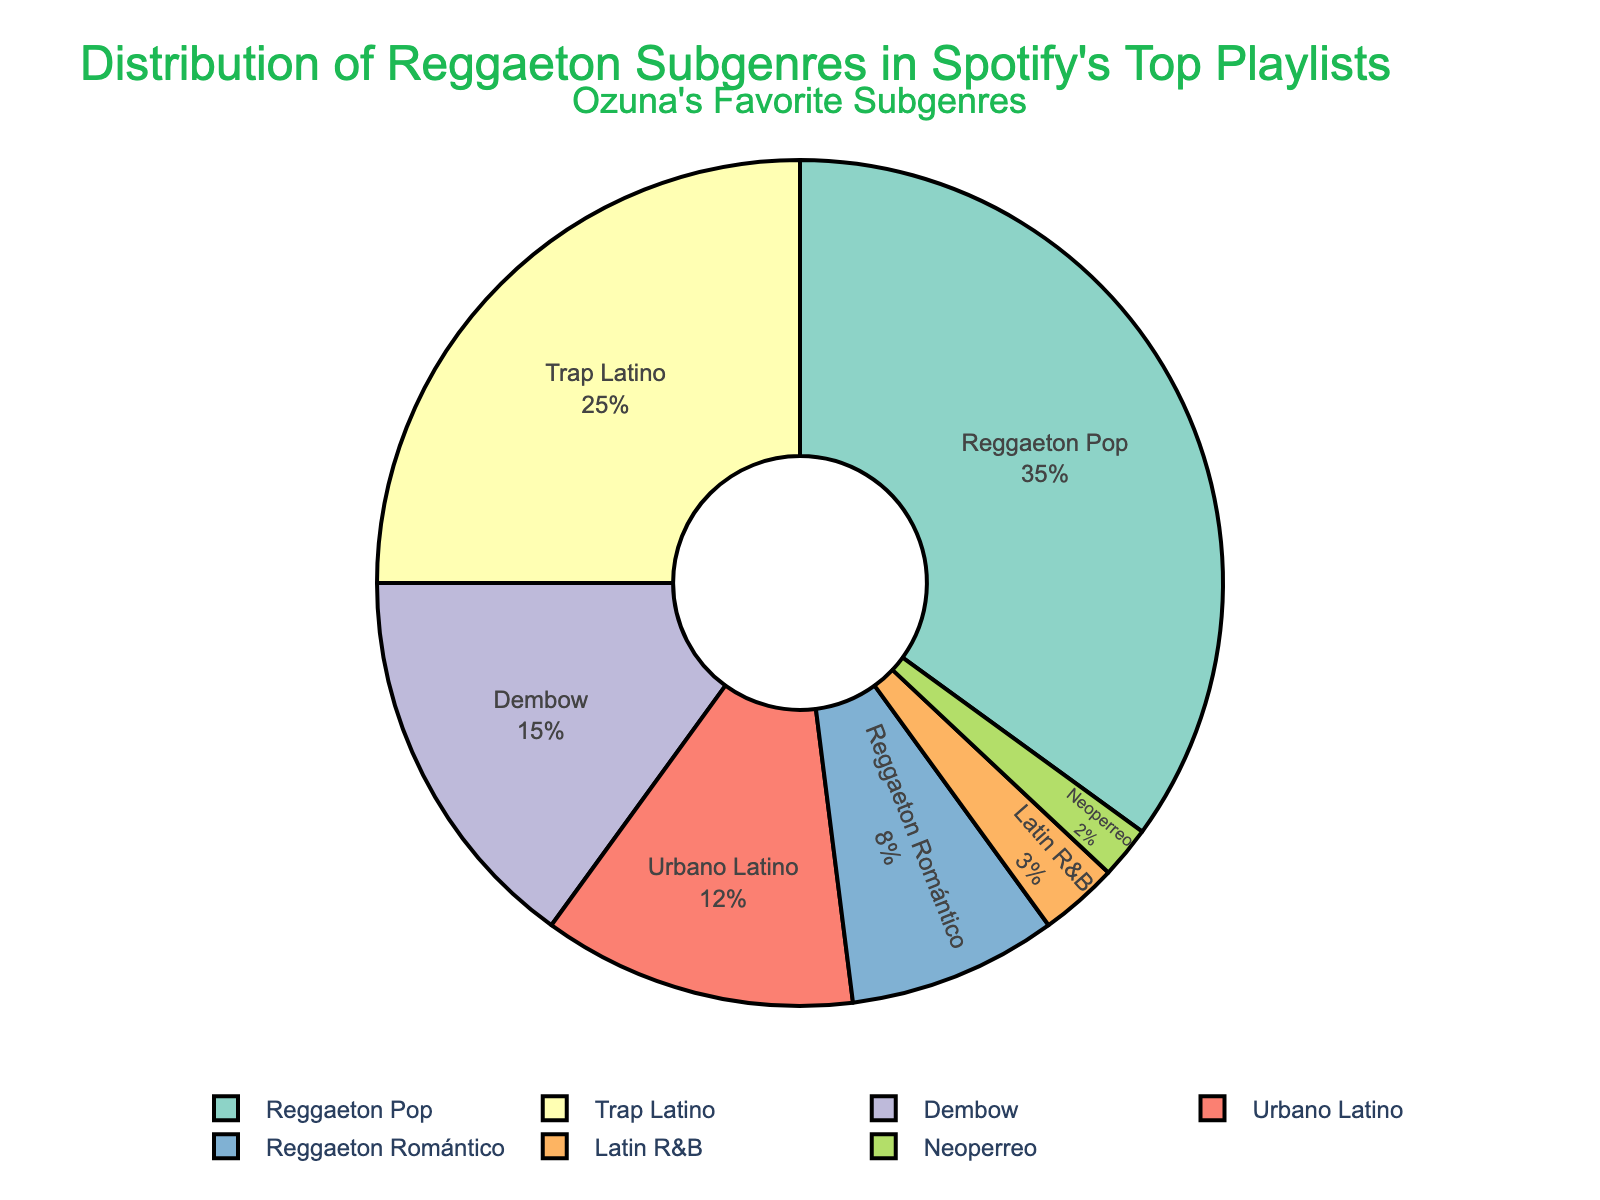What's the most popular reggaeton subgenre in Spotify's top playlists? The pie chart shows that "Reggaeton Pop" has the largest slice, representing 35% of the total distribution, which is the highest percentage among all subgenres.
Answer: Reggaeton Pop How much more popular is Trap Latino compared to Reggaeton Romántico? Trap Latino has 25% and Reggaeton Romántico has 8%. By subtracting 8% from 25%, we get the difference.
Answer: 17% What is the combined percentage of Dembow and Urbano Latino? Dembow has 15% and Urbano Latino has 12%. Adding these two percentages together results in 27%.
Answer: 27% Which subgenre has the smallest percentage? Neoperreo has the smallest slice in the pie chart, representing 2% of the total distribution.
Answer: Neoperreo How much smaller is Latin R&B's share compared to Urbano Latino's? Urbano Latino is 12% and Latin R&B is 3%. By subtracting 3% from 12%, you get the difference.
Answer: 9% Which two subgenres together make up exactly half of Spotify's top playlists? The top two subgenres are Reggaeton Pop and Trap Latino, which are 35% and 25%, respectively. Adding these two percentages together gives 60%, not 50%. Checking the next possible pairs: Dembow and Urbano Latino, which are 15% and 12%, totaling 27%; none of these pairings add up to exactly 50%.
Answer: None (there's no such pair) What is the average percentage of all reggaeton subgenres listed in the pie chart? The percentages are 35, 25, 15, 12, 8, 3, and 2. Summing them equals 100 which is the total distribution. Dividing 100 by 7 (total subgenres) gives approximately 14.3%.
Answer: 14.3% If you were to combine Reggaeton Romántico and Neoperreo, what percentage would they constitute together? Reggaeton Romántico is 8% and Neoperreo is 2%. Adding these two percentages together results in 10%.
Answer: 10% How many subgenres have a share of 10% or more in Spotify's top playlists? We see that Reggaeton Pop (35%), Trap Latino (25%), Dembow (15%), and Urbano Latino (12%) each have more than 10%.
Answer: 4 What is the percentage difference between the largest and smallest subgenres? The largest subgenre (Reggaeton Pop) has 35% and the smallest (Neoperreo) has 2%. Subtracting 2% from 35% gives a difference of 33%.
Answer: 33% 